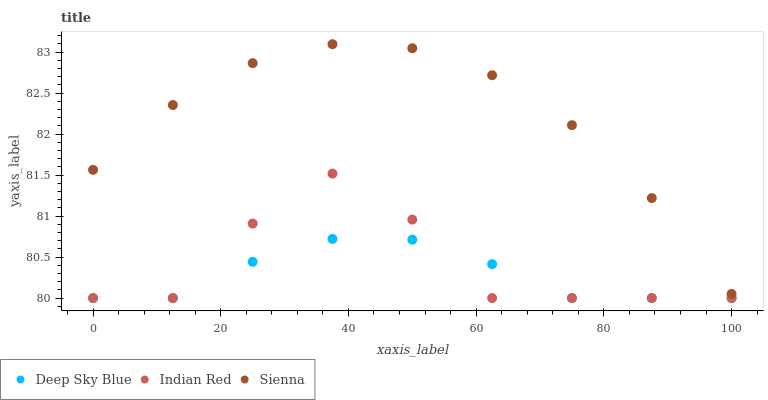Does Deep Sky Blue have the minimum area under the curve?
Answer yes or no. Yes. Does Sienna have the maximum area under the curve?
Answer yes or no. Yes. Does Indian Red have the minimum area under the curve?
Answer yes or no. No. Does Indian Red have the maximum area under the curve?
Answer yes or no. No. Is Deep Sky Blue the smoothest?
Answer yes or no. Yes. Is Indian Red the roughest?
Answer yes or no. Yes. Is Indian Red the smoothest?
Answer yes or no. No. Is Deep Sky Blue the roughest?
Answer yes or no. No. Does Indian Red have the lowest value?
Answer yes or no. Yes. Does Sienna have the highest value?
Answer yes or no. Yes. Does Indian Red have the highest value?
Answer yes or no. No. Is Deep Sky Blue less than Sienna?
Answer yes or no. Yes. Is Sienna greater than Indian Red?
Answer yes or no. Yes. Does Deep Sky Blue intersect Indian Red?
Answer yes or no. Yes. Is Deep Sky Blue less than Indian Red?
Answer yes or no. No. Is Deep Sky Blue greater than Indian Red?
Answer yes or no. No. Does Deep Sky Blue intersect Sienna?
Answer yes or no. No. 